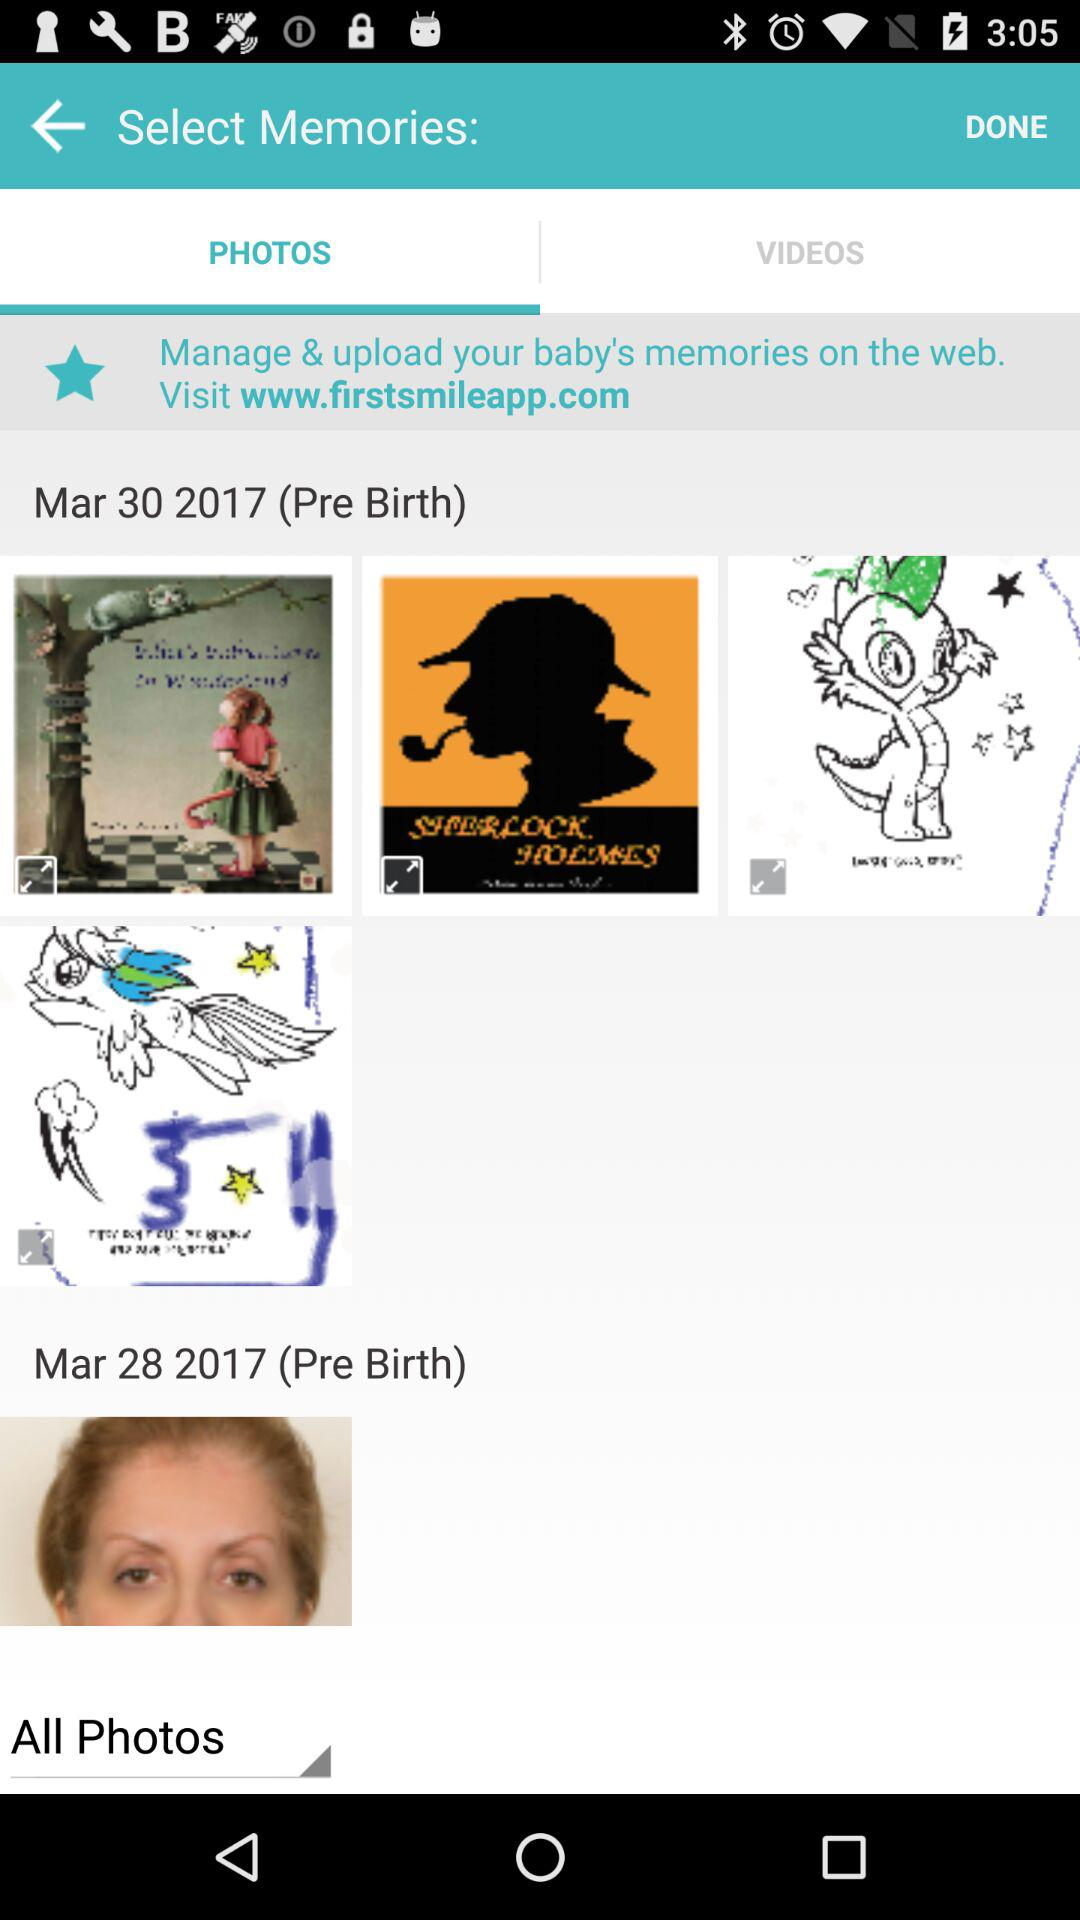Which option is selected? The selected options are "PHOTOS" and "All Photos". 